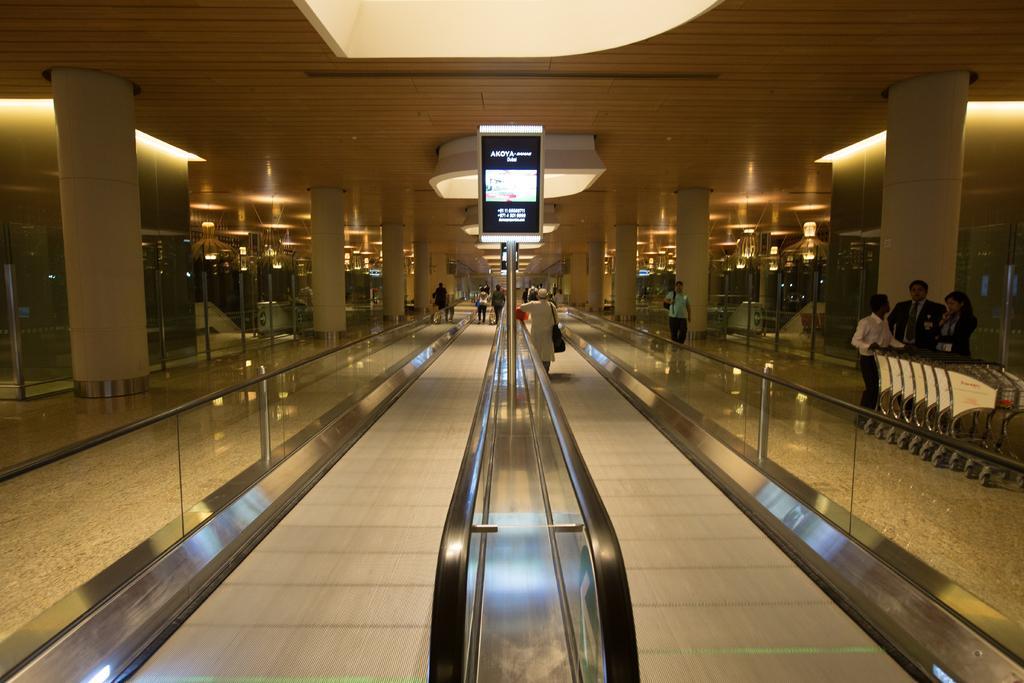Describe this image in one or two sentences. In this image there are walking band escalators , a person standing on the walking band escalator, group of people standing, trolleys, a screen to the pole, lights, pillars. 